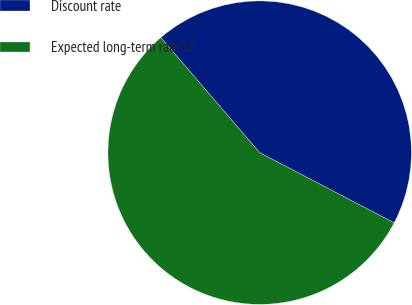<chart> <loc_0><loc_0><loc_500><loc_500><pie_chart><fcel>Discount rate<fcel>Expected long-term rate of<nl><fcel>43.96%<fcel>56.04%<nl></chart> 